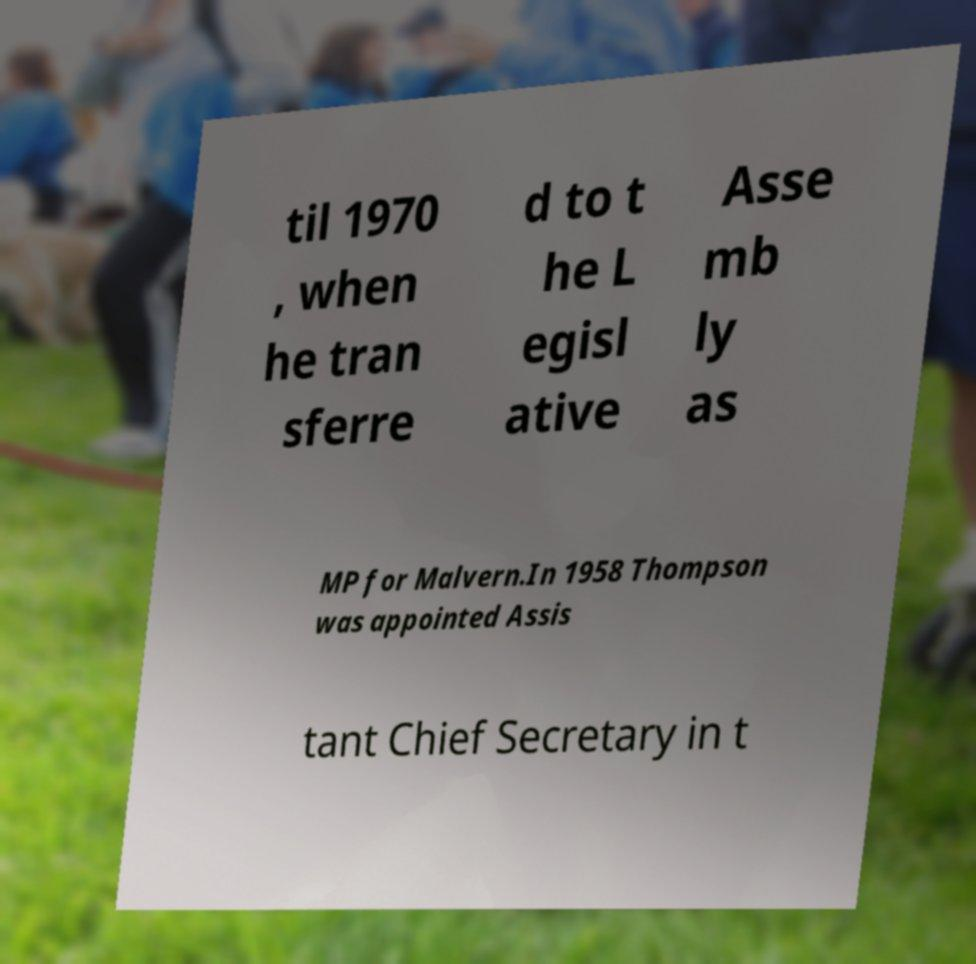Please identify and transcribe the text found in this image. til 1970 , when he tran sferre d to t he L egisl ative Asse mb ly as MP for Malvern.In 1958 Thompson was appointed Assis tant Chief Secretary in t 